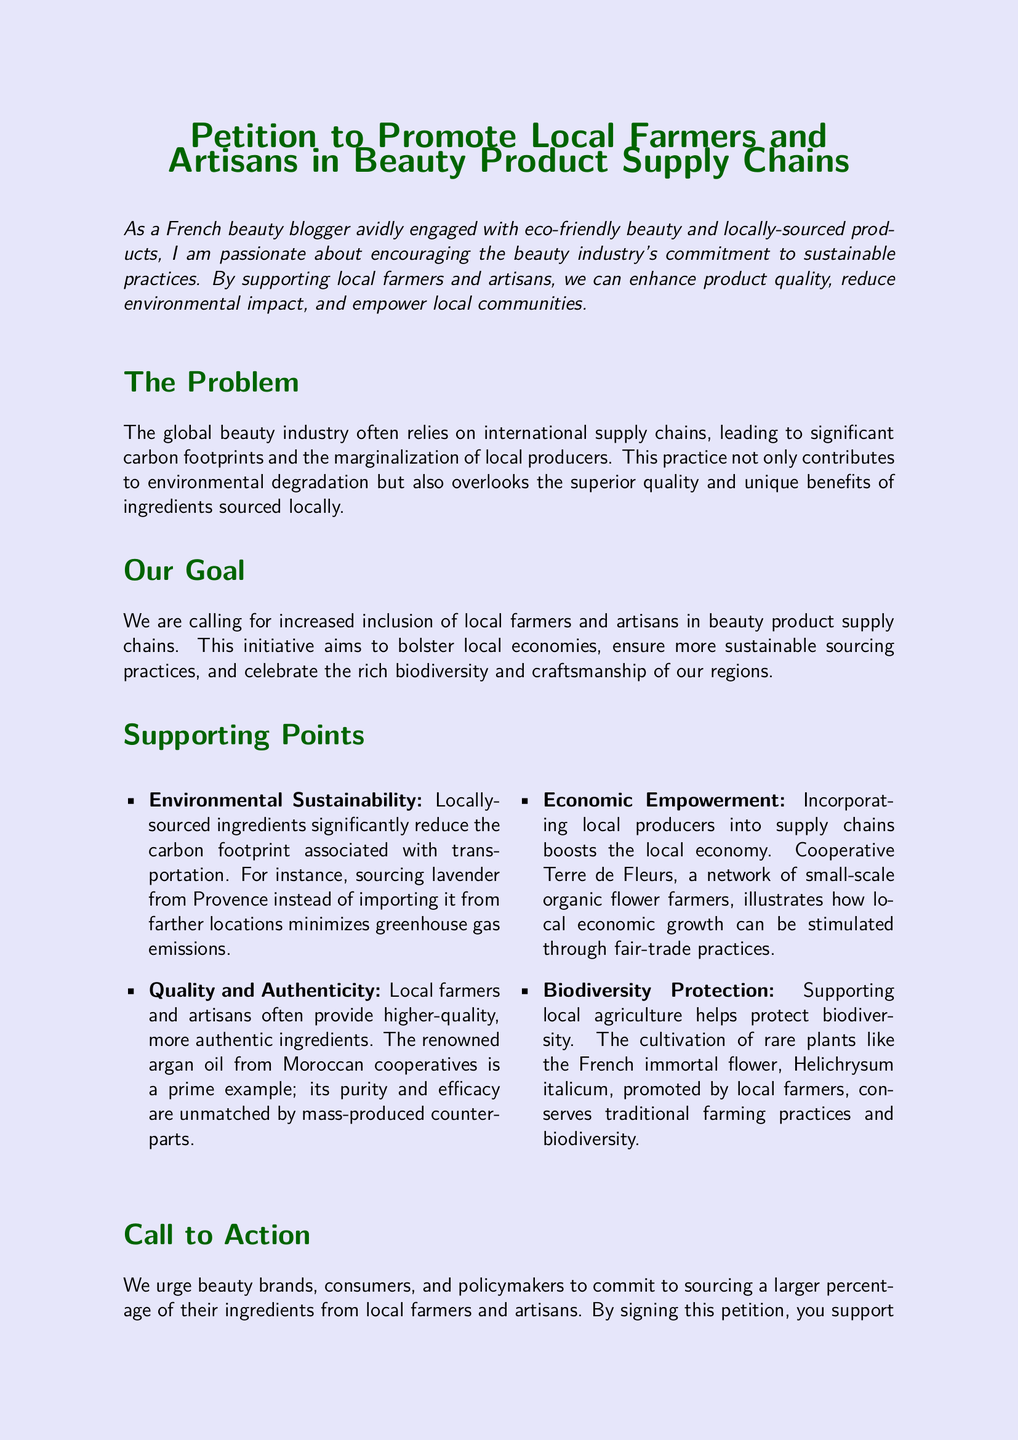What is the title of the petition? The title of the petition is clearly stated at the top of the document.
Answer: Petition to Promote Local Farmers and Artisans in Beauty Product Supply Chains What is one environmental benefit of locally-sourced ingredients? The document mentions that locally-sourced ingredients significantly reduce the carbon footprint.
Answer: Reduced carbon footprint What is an example of a locally-sourced ingredient mentioned in the petition? The petition provides an example of lavender sourced from Provence.
Answer: Lavender Who benefits economically from the proposed initiative? The document highlights how local producers benefit from increased inclusion in supply chains.
Answer: Local economies What type of flower is mentioned in relation to biodiversity protection? The petition refers to Helichrysum italicum as a rare plant that helps protect biodiversity.
Answer: Helichrysum italicum What does the petition urge beauty brands and policymakers to do? The document calls for a larger percentage of ingredients to be sourced from local farmers and artisans.
Answer: Source a larger percentage of ingredients locally What is the name of the cooperative that demonstrates economic empowerment? The cooperative mentioned in the document is Terre de Fleurs.
Answer: Terre de Fleurs What are people encouraged to do at the end of the petition? The document includes a call to action for signing the petition.
Answer: Sign the petition 